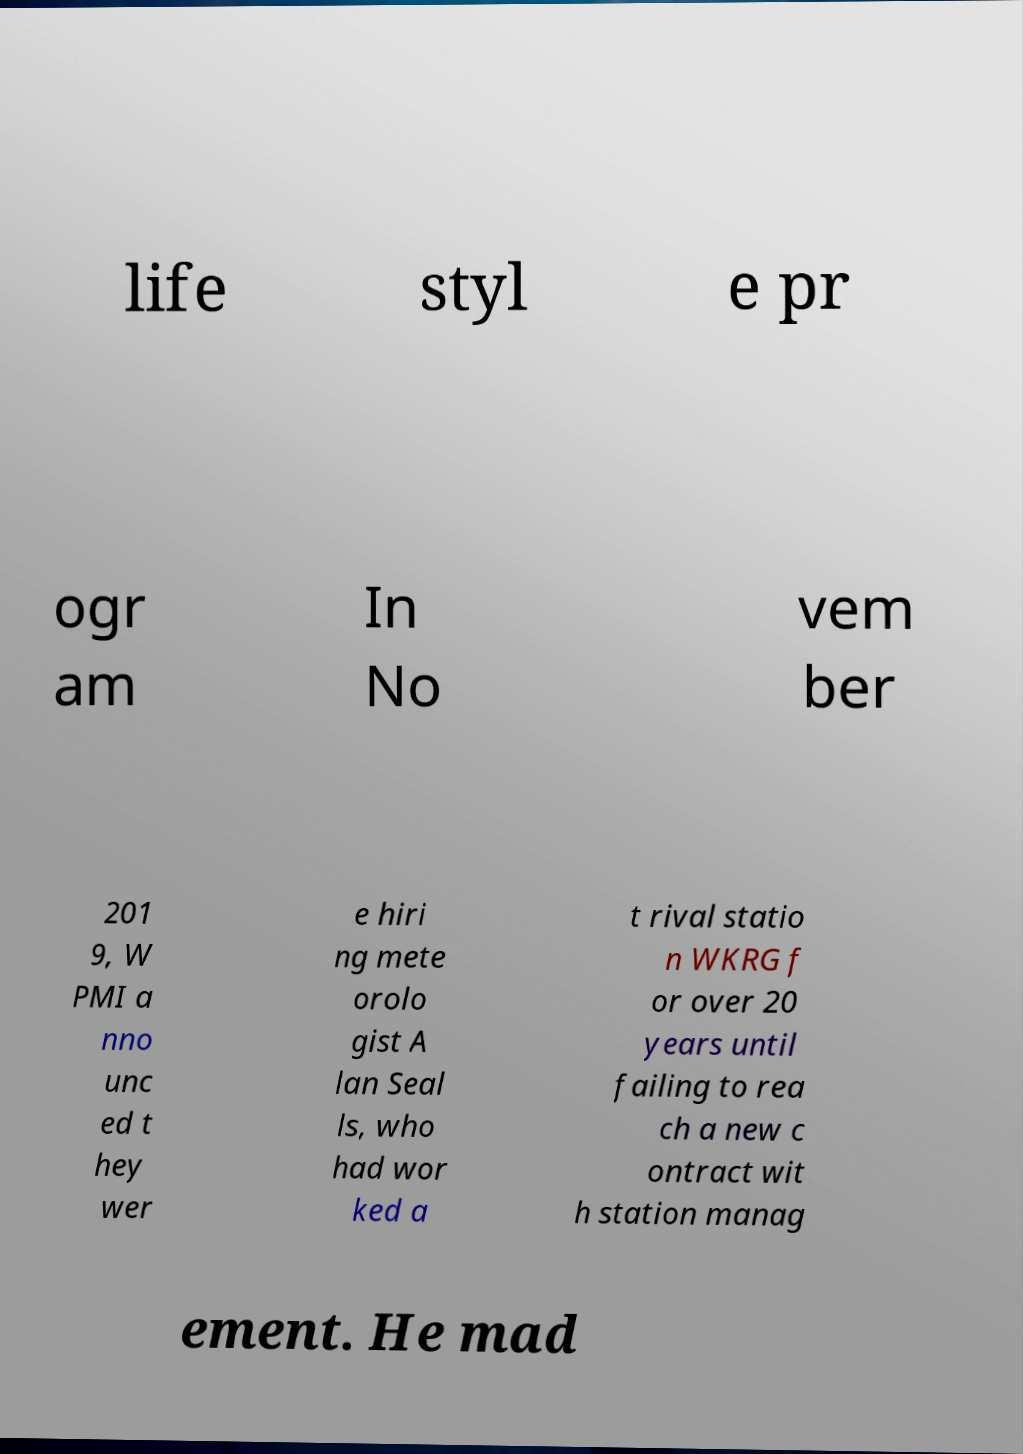Could you assist in decoding the text presented in this image and type it out clearly? life styl e pr ogr am In No vem ber 201 9, W PMI a nno unc ed t hey wer e hiri ng mete orolo gist A lan Seal ls, who had wor ked a t rival statio n WKRG f or over 20 years until failing to rea ch a new c ontract wit h station manag ement. He mad 